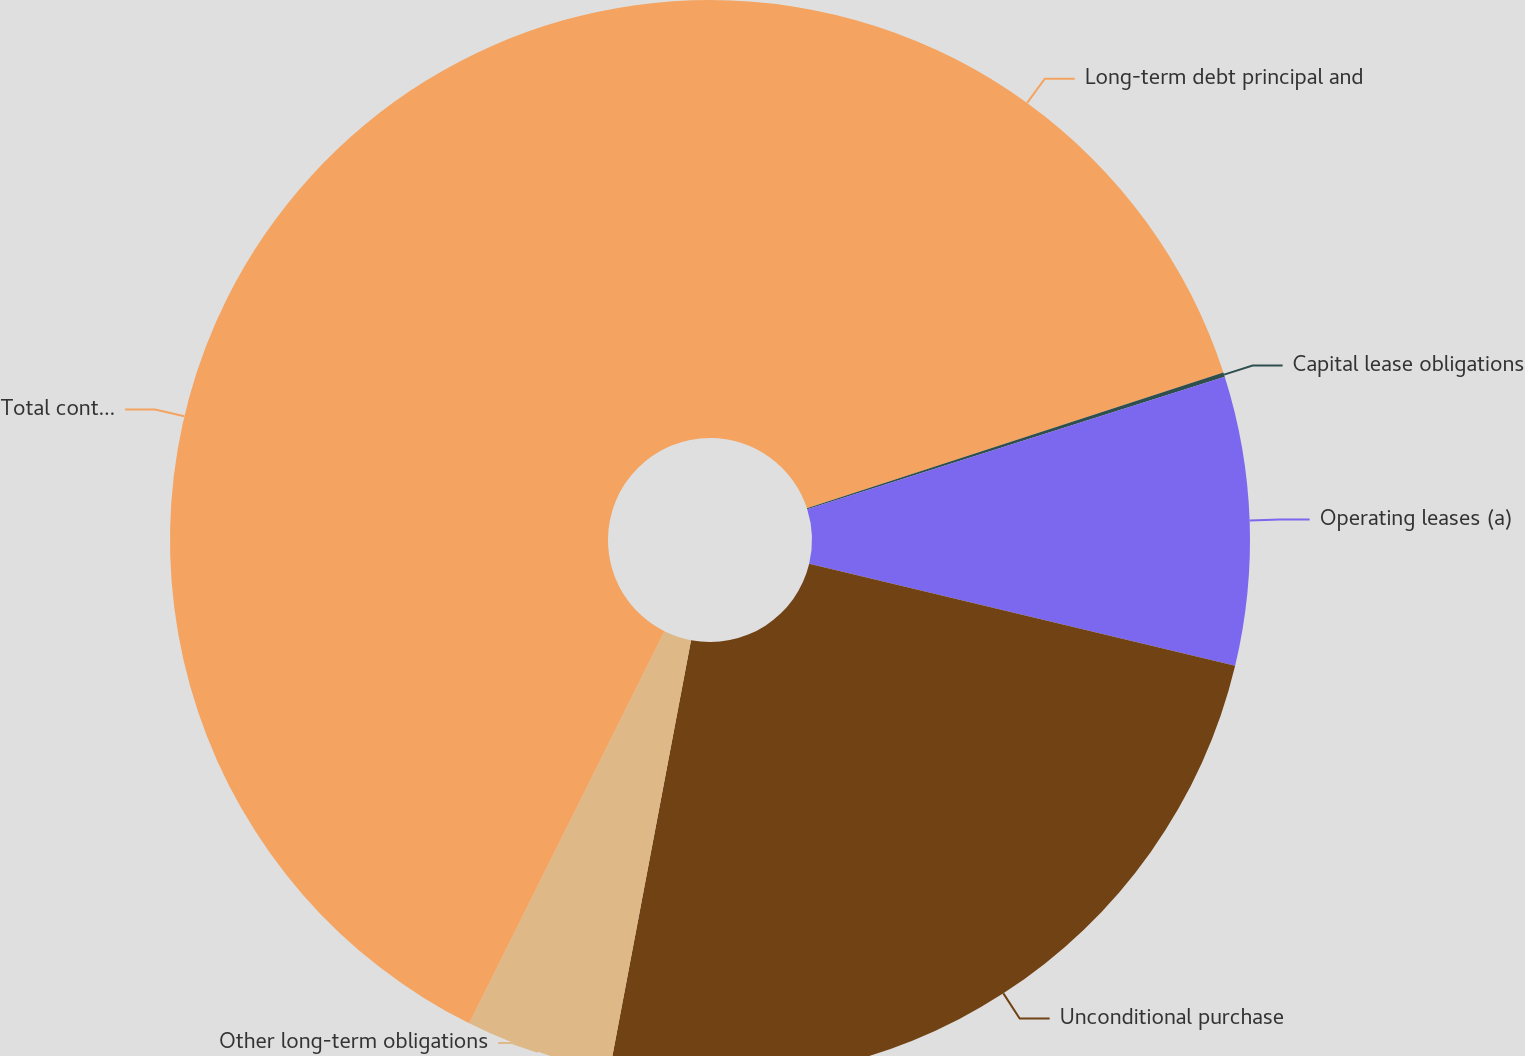Convert chart. <chart><loc_0><loc_0><loc_500><loc_500><pie_chart><fcel>Long-term debt principal and<fcel>Capital lease obligations<fcel>Operating leases (a)<fcel>Unconditional purchase<fcel>Other long-term obligations<fcel>Total contractual cash<nl><fcel>19.98%<fcel>0.13%<fcel>8.63%<fcel>24.23%<fcel>4.38%<fcel>42.64%<nl></chart> 